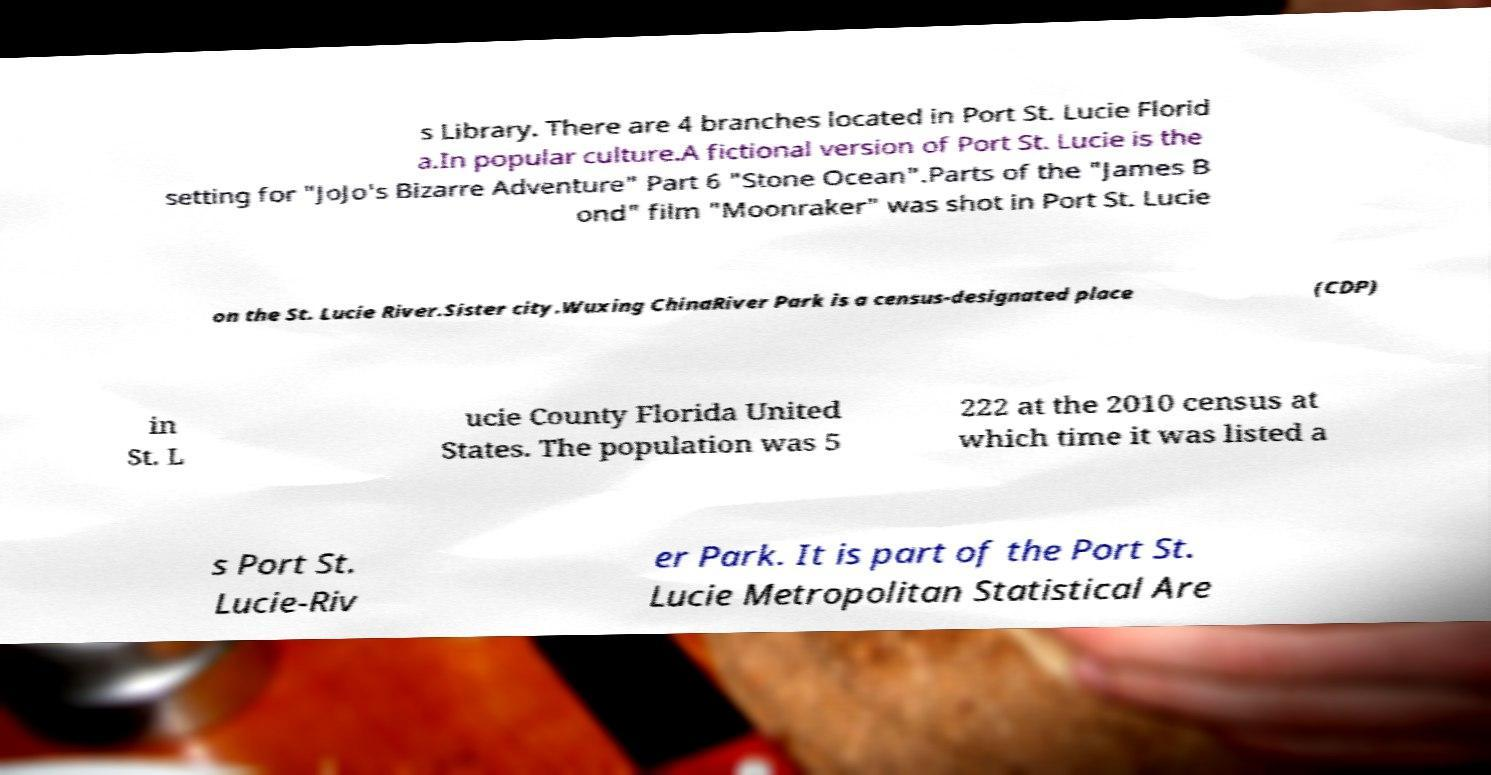For documentation purposes, I need the text within this image transcribed. Could you provide that? s Library. There are 4 branches located in Port St. Lucie Florid a.In popular culture.A fictional version of Port St. Lucie is the setting for "JoJo's Bizarre Adventure" Part 6 "Stone Ocean".Parts of the "James B ond" film "Moonraker" was shot in Port St. Lucie on the St. Lucie River.Sister city.Wuxing ChinaRiver Park is a census-designated place (CDP) in St. L ucie County Florida United States. The population was 5 222 at the 2010 census at which time it was listed a s Port St. Lucie-Riv er Park. It is part of the Port St. Lucie Metropolitan Statistical Are 